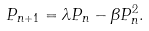Convert formula to latex. <formula><loc_0><loc_0><loc_500><loc_500>P _ { n + 1 } = \lambda P _ { n } - \beta P _ { n } ^ { 2 } .</formula> 